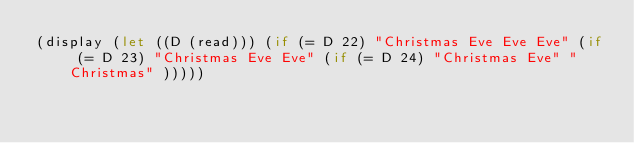<code> <loc_0><loc_0><loc_500><loc_500><_Scheme_>(display (let ((D (read))) (if (= D 22) "Christmas Eve Eve Eve" (if (= D 23) "Christmas Eve Eve" (if (= D 24) "Christmas Eve" "Christmas" )))))</code> 